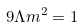<formula> <loc_0><loc_0><loc_500><loc_500>9 \Lambda m ^ { 2 } = 1</formula> 